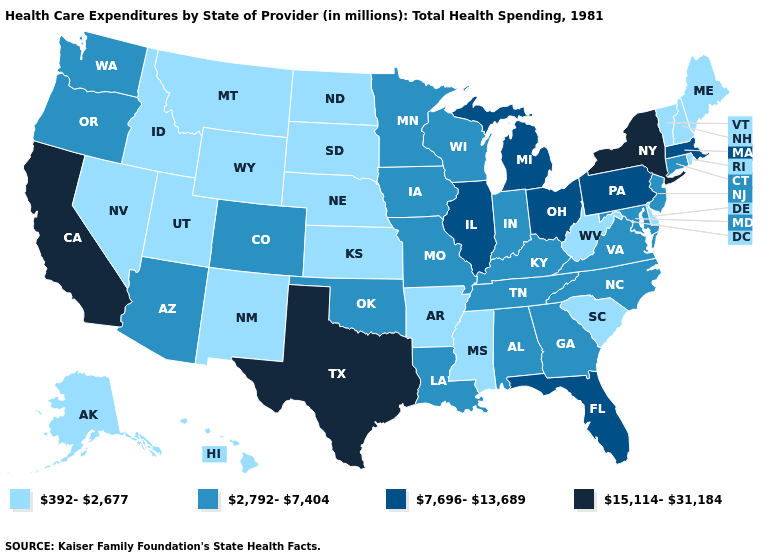Does Wisconsin have the lowest value in the USA?
Concise answer only. No. What is the value of Louisiana?
Give a very brief answer. 2,792-7,404. What is the lowest value in states that border Montana?
Short answer required. 392-2,677. Does New York have the highest value in the Northeast?
Quick response, please. Yes. What is the value of Washington?
Be succinct. 2,792-7,404. Name the states that have a value in the range 15,114-31,184?
Give a very brief answer. California, New York, Texas. Among the states that border Rhode Island , which have the highest value?
Quick response, please. Massachusetts. Does Kansas have a lower value than Minnesota?
Write a very short answer. Yes. What is the value of Georgia?
Answer briefly. 2,792-7,404. Does Rhode Island have the highest value in the Northeast?
Quick response, please. No. Name the states that have a value in the range 392-2,677?
Answer briefly. Alaska, Arkansas, Delaware, Hawaii, Idaho, Kansas, Maine, Mississippi, Montana, Nebraska, Nevada, New Hampshire, New Mexico, North Dakota, Rhode Island, South Carolina, South Dakota, Utah, Vermont, West Virginia, Wyoming. What is the lowest value in states that border New Hampshire?
Be succinct. 392-2,677. Does Connecticut have a lower value than Michigan?
Answer briefly. Yes. Is the legend a continuous bar?
Short answer required. No. Does Connecticut have a lower value than Massachusetts?
Quick response, please. Yes. 